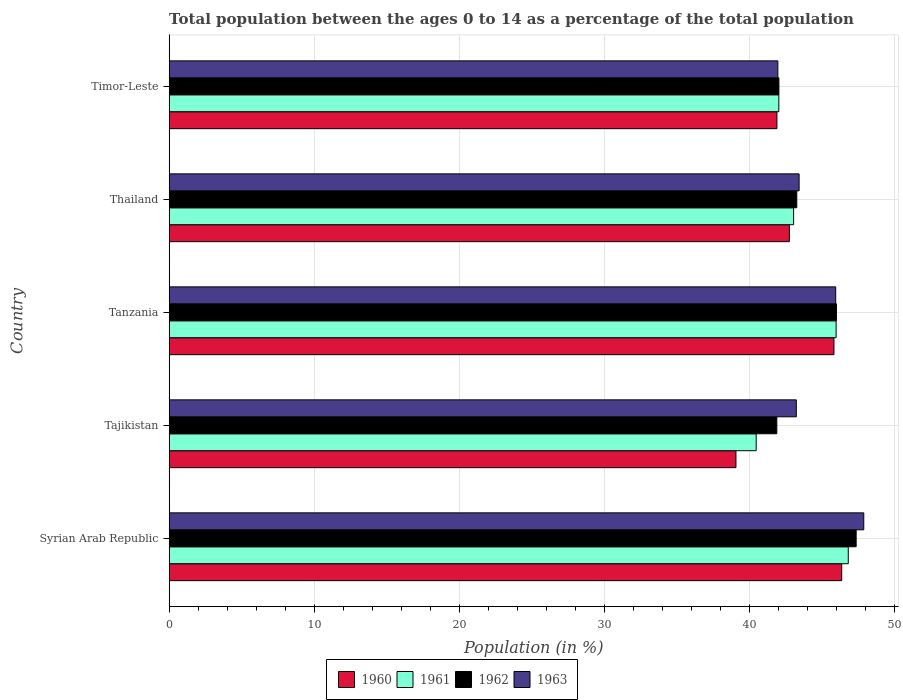How many groups of bars are there?
Offer a terse response. 5. How many bars are there on the 2nd tick from the bottom?
Make the answer very short. 4. What is the label of the 3rd group of bars from the top?
Keep it short and to the point. Tanzania. What is the percentage of the population ages 0 to 14 in 1963 in Tanzania?
Give a very brief answer. 45.93. Across all countries, what is the maximum percentage of the population ages 0 to 14 in 1960?
Offer a terse response. 46.34. Across all countries, what is the minimum percentage of the population ages 0 to 14 in 1962?
Provide a short and direct response. 41.87. In which country was the percentage of the population ages 0 to 14 in 1960 maximum?
Your answer should be very brief. Syrian Arab Republic. In which country was the percentage of the population ages 0 to 14 in 1962 minimum?
Your answer should be compact. Tajikistan. What is the total percentage of the population ages 0 to 14 in 1963 in the graph?
Your answer should be compact. 222.36. What is the difference between the percentage of the population ages 0 to 14 in 1962 in Syrian Arab Republic and that in Timor-Leste?
Offer a very short reply. 5.32. What is the difference between the percentage of the population ages 0 to 14 in 1961 in Timor-Leste and the percentage of the population ages 0 to 14 in 1963 in Thailand?
Provide a succinct answer. -1.4. What is the average percentage of the population ages 0 to 14 in 1960 per country?
Give a very brief answer. 43.16. What is the difference between the percentage of the population ages 0 to 14 in 1962 and percentage of the population ages 0 to 14 in 1960 in Thailand?
Your answer should be compact. 0.51. In how many countries, is the percentage of the population ages 0 to 14 in 1961 greater than 28 ?
Offer a very short reply. 5. What is the ratio of the percentage of the population ages 0 to 14 in 1962 in Tanzania to that in Thailand?
Your answer should be very brief. 1.06. Is the percentage of the population ages 0 to 14 in 1960 in Tanzania less than that in Timor-Leste?
Provide a short and direct response. No. Is the difference between the percentage of the population ages 0 to 14 in 1962 in Tajikistan and Timor-Leste greater than the difference between the percentage of the population ages 0 to 14 in 1960 in Tajikistan and Timor-Leste?
Ensure brevity in your answer.  Yes. What is the difference between the highest and the second highest percentage of the population ages 0 to 14 in 1963?
Provide a short and direct response. 1.93. What is the difference between the highest and the lowest percentage of the population ages 0 to 14 in 1960?
Provide a succinct answer. 7.29. Is the sum of the percentage of the population ages 0 to 14 in 1962 in Syrian Arab Republic and Tanzania greater than the maximum percentage of the population ages 0 to 14 in 1960 across all countries?
Your answer should be compact. Yes. Is it the case that in every country, the sum of the percentage of the population ages 0 to 14 in 1960 and percentage of the population ages 0 to 14 in 1962 is greater than the sum of percentage of the population ages 0 to 14 in 1963 and percentage of the population ages 0 to 14 in 1961?
Make the answer very short. No. What does the 3rd bar from the top in Tanzania represents?
Offer a terse response. 1961. What does the 3rd bar from the bottom in Syrian Arab Republic represents?
Your response must be concise. 1962. Is it the case that in every country, the sum of the percentage of the population ages 0 to 14 in 1961 and percentage of the population ages 0 to 14 in 1962 is greater than the percentage of the population ages 0 to 14 in 1960?
Offer a terse response. Yes. How many bars are there?
Offer a terse response. 20. How many countries are there in the graph?
Make the answer very short. 5. What is the difference between two consecutive major ticks on the X-axis?
Your answer should be compact. 10. Does the graph contain any zero values?
Keep it short and to the point. No. What is the title of the graph?
Provide a short and direct response. Total population between the ages 0 to 14 as a percentage of the total population. Does "1963" appear as one of the legend labels in the graph?
Offer a terse response. Yes. What is the label or title of the X-axis?
Make the answer very short. Population (in %). What is the Population (in %) in 1960 in Syrian Arab Republic?
Make the answer very short. 46.34. What is the Population (in %) of 1961 in Syrian Arab Republic?
Provide a short and direct response. 46.79. What is the Population (in %) in 1962 in Syrian Arab Republic?
Ensure brevity in your answer.  47.34. What is the Population (in %) in 1963 in Syrian Arab Republic?
Your response must be concise. 47.86. What is the Population (in %) in 1960 in Tajikistan?
Provide a short and direct response. 39.06. What is the Population (in %) in 1961 in Tajikistan?
Give a very brief answer. 40.45. What is the Population (in %) in 1962 in Tajikistan?
Your answer should be compact. 41.87. What is the Population (in %) of 1963 in Tajikistan?
Provide a succinct answer. 43.22. What is the Population (in %) in 1960 in Tanzania?
Ensure brevity in your answer.  45.81. What is the Population (in %) of 1961 in Tanzania?
Your answer should be very brief. 45.96. What is the Population (in %) of 1962 in Tanzania?
Give a very brief answer. 45.98. What is the Population (in %) in 1963 in Tanzania?
Your answer should be compact. 45.93. What is the Population (in %) of 1960 in Thailand?
Ensure brevity in your answer.  42.73. What is the Population (in %) of 1961 in Thailand?
Give a very brief answer. 43.03. What is the Population (in %) of 1962 in Thailand?
Make the answer very short. 43.25. What is the Population (in %) of 1963 in Thailand?
Give a very brief answer. 43.41. What is the Population (in %) in 1960 in Timor-Leste?
Make the answer very short. 41.88. What is the Population (in %) of 1961 in Timor-Leste?
Provide a short and direct response. 42.01. What is the Population (in %) of 1962 in Timor-Leste?
Your response must be concise. 42.02. What is the Population (in %) of 1963 in Timor-Leste?
Provide a short and direct response. 41.94. Across all countries, what is the maximum Population (in %) of 1960?
Make the answer very short. 46.34. Across all countries, what is the maximum Population (in %) in 1961?
Your response must be concise. 46.79. Across all countries, what is the maximum Population (in %) of 1962?
Your answer should be compact. 47.34. Across all countries, what is the maximum Population (in %) in 1963?
Your answer should be compact. 47.86. Across all countries, what is the minimum Population (in %) of 1960?
Offer a very short reply. 39.06. Across all countries, what is the minimum Population (in %) of 1961?
Your answer should be very brief. 40.45. Across all countries, what is the minimum Population (in %) of 1962?
Make the answer very short. 41.87. Across all countries, what is the minimum Population (in %) of 1963?
Your answer should be very brief. 41.94. What is the total Population (in %) of 1960 in the graph?
Your answer should be very brief. 215.82. What is the total Population (in %) in 1961 in the graph?
Your answer should be compact. 218.24. What is the total Population (in %) in 1962 in the graph?
Offer a very short reply. 220.45. What is the total Population (in %) of 1963 in the graph?
Your answer should be compact. 222.36. What is the difference between the Population (in %) of 1960 in Syrian Arab Republic and that in Tajikistan?
Offer a very short reply. 7.29. What is the difference between the Population (in %) of 1961 in Syrian Arab Republic and that in Tajikistan?
Your response must be concise. 6.34. What is the difference between the Population (in %) in 1962 in Syrian Arab Republic and that in Tajikistan?
Ensure brevity in your answer.  5.47. What is the difference between the Population (in %) in 1963 in Syrian Arab Republic and that in Tajikistan?
Offer a very short reply. 4.65. What is the difference between the Population (in %) of 1960 in Syrian Arab Republic and that in Tanzania?
Your response must be concise. 0.53. What is the difference between the Population (in %) in 1961 in Syrian Arab Republic and that in Tanzania?
Ensure brevity in your answer.  0.84. What is the difference between the Population (in %) of 1962 in Syrian Arab Republic and that in Tanzania?
Provide a succinct answer. 1.36. What is the difference between the Population (in %) in 1963 in Syrian Arab Republic and that in Tanzania?
Offer a terse response. 1.93. What is the difference between the Population (in %) in 1960 in Syrian Arab Republic and that in Thailand?
Offer a very short reply. 3.61. What is the difference between the Population (in %) of 1961 in Syrian Arab Republic and that in Thailand?
Keep it short and to the point. 3.77. What is the difference between the Population (in %) of 1962 in Syrian Arab Republic and that in Thailand?
Offer a very short reply. 4.09. What is the difference between the Population (in %) in 1963 in Syrian Arab Republic and that in Thailand?
Make the answer very short. 4.46. What is the difference between the Population (in %) in 1960 in Syrian Arab Republic and that in Timor-Leste?
Keep it short and to the point. 4.46. What is the difference between the Population (in %) of 1961 in Syrian Arab Republic and that in Timor-Leste?
Your answer should be very brief. 4.78. What is the difference between the Population (in %) in 1962 in Syrian Arab Republic and that in Timor-Leste?
Make the answer very short. 5.32. What is the difference between the Population (in %) of 1963 in Syrian Arab Republic and that in Timor-Leste?
Give a very brief answer. 5.92. What is the difference between the Population (in %) of 1960 in Tajikistan and that in Tanzania?
Your answer should be compact. -6.75. What is the difference between the Population (in %) of 1961 in Tajikistan and that in Tanzania?
Offer a terse response. -5.51. What is the difference between the Population (in %) of 1962 in Tajikistan and that in Tanzania?
Ensure brevity in your answer.  -4.11. What is the difference between the Population (in %) of 1963 in Tajikistan and that in Tanzania?
Provide a succinct answer. -2.71. What is the difference between the Population (in %) of 1960 in Tajikistan and that in Thailand?
Your answer should be compact. -3.68. What is the difference between the Population (in %) in 1961 in Tajikistan and that in Thailand?
Give a very brief answer. -2.58. What is the difference between the Population (in %) in 1962 in Tajikistan and that in Thailand?
Make the answer very short. -1.38. What is the difference between the Population (in %) of 1963 in Tajikistan and that in Thailand?
Keep it short and to the point. -0.19. What is the difference between the Population (in %) in 1960 in Tajikistan and that in Timor-Leste?
Your response must be concise. -2.82. What is the difference between the Population (in %) in 1961 in Tajikistan and that in Timor-Leste?
Provide a succinct answer. -1.56. What is the difference between the Population (in %) in 1962 in Tajikistan and that in Timor-Leste?
Your response must be concise. -0.14. What is the difference between the Population (in %) in 1963 in Tajikistan and that in Timor-Leste?
Provide a short and direct response. 1.27. What is the difference between the Population (in %) in 1960 in Tanzania and that in Thailand?
Your response must be concise. 3.07. What is the difference between the Population (in %) in 1961 in Tanzania and that in Thailand?
Provide a short and direct response. 2.93. What is the difference between the Population (in %) in 1962 in Tanzania and that in Thailand?
Ensure brevity in your answer.  2.73. What is the difference between the Population (in %) of 1963 in Tanzania and that in Thailand?
Make the answer very short. 2.52. What is the difference between the Population (in %) of 1960 in Tanzania and that in Timor-Leste?
Offer a terse response. 3.93. What is the difference between the Population (in %) of 1961 in Tanzania and that in Timor-Leste?
Your answer should be compact. 3.95. What is the difference between the Population (in %) of 1962 in Tanzania and that in Timor-Leste?
Offer a very short reply. 3.96. What is the difference between the Population (in %) in 1963 in Tanzania and that in Timor-Leste?
Ensure brevity in your answer.  3.99. What is the difference between the Population (in %) of 1960 in Thailand and that in Timor-Leste?
Give a very brief answer. 0.86. What is the difference between the Population (in %) in 1961 in Thailand and that in Timor-Leste?
Make the answer very short. 1.02. What is the difference between the Population (in %) in 1962 in Thailand and that in Timor-Leste?
Your answer should be compact. 1.23. What is the difference between the Population (in %) of 1963 in Thailand and that in Timor-Leste?
Keep it short and to the point. 1.47. What is the difference between the Population (in %) in 1960 in Syrian Arab Republic and the Population (in %) in 1961 in Tajikistan?
Provide a succinct answer. 5.89. What is the difference between the Population (in %) of 1960 in Syrian Arab Republic and the Population (in %) of 1962 in Tajikistan?
Your response must be concise. 4.47. What is the difference between the Population (in %) of 1960 in Syrian Arab Republic and the Population (in %) of 1963 in Tajikistan?
Your answer should be compact. 3.13. What is the difference between the Population (in %) in 1961 in Syrian Arab Republic and the Population (in %) in 1962 in Tajikistan?
Your answer should be compact. 4.92. What is the difference between the Population (in %) in 1961 in Syrian Arab Republic and the Population (in %) in 1963 in Tajikistan?
Make the answer very short. 3.58. What is the difference between the Population (in %) in 1962 in Syrian Arab Republic and the Population (in %) in 1963 in Tajikistan?
Your answer should be very brief. 4.12. What is the difference between the Population (in %) in 1960 in Syrian Arab Republic and the Population (in %) in 1961 in Tanzania?
Make the answer very short. 0.39. What is the difference between the Population (in %) in 1960 in Syrian Arab Republic and the Population (in %) in 1962 in Tanzania?
Offer a terse response. 0.36. What is the difference between the Population (in %) in 1960 in Syrian Arab Republic and the Population (in %) in 1963 in Tanzania?
Offer a terse response. 0.41. What is the difference between the Population (in %) of 1961 in Syrian Arab Republic and the Population (in %) of 1962 in Tanzania?
Keep it short and to the point. 0.81. What is the difference between the Population (in %) of 1961 in Syrian Arab Republic and the Population (in %) of 1963 in Tanzania?
Your response must be concise. 0.87. What is the difference between the Population (in %) of 1962 in Syrian Arab Republic and the Population (in %) of 1963 in Tanzania?
Provide a succinct answer. 1.41. What is the difference between the Population (in %) in 1960 in Syrian Arab Republic and the Population (in %) in 1961 in Thailand?
Provide a short and direct response. 3.31. What is the difference between the Population (in %) in 1960 in Syrian Arab Republic and the Population (in %) in 1962 in Thailand?
Offer a terse response. 3.1. What is the difference between the Population (in %) in 1960 in Syrian Arab Republic and the Population (in %) in 1963 in Thailand?
Give a very brief answer. 2.94. What is the difference between the Population (in %) in 1961 in Syrian Arab Republic and the Population (in %) in 1962 in Thailand?
Your response must be concise. 3.55. What is the difference between the Population (in %) in 1961 in Syrian Arab Republic and the Population (in %) in 1963 in Thailand?
Your response must be concise. 3.39. What is the difference between the Population (in %) in 1962 in Syrian Arab Republic and the Population (in %) in 1963 in Thailand?
Give a very brief answer. 3.93. What is the difference between the Population (in %) of 1960 in Syrian Arab Republic and the Population (in %) of 1961 in Timor-Leste?
Ensure brevity in your answer.  4.33. What is the difference between the Population (in %) in 1960 in Syrian Arab Republic and the Population (in %) in 1962 in Timor-Leste?
Provide a succinct answer. 4.33. What is the difference between the Population (in %) of 1960 in Syrian Arab Republic and the Population (in %) of 1963 in Timor-Leste?
Provide a short and direct response. 4.4. What is the difference between the Population (in %) in 1961 in Syrian Arab Republic and the Population (in %) in 1962 in Timor-Leste?
Give a very brief answer. 4.78. What is the difference between the Population (in %) in 1961 in Syrian Arab Republic and the Population (in %) in 1963 in Timor-Leste?
Make the answer very short. 4.85. What is the difference between the Population (in %) in 1962 in Syrian Arab Republic and the Population (in %) in 1963 in Timor-Leste?
Ensure brevity in your answer.  5.4. What is the difference between the Population (in %) of 1960 in Tajikistan and the Population (in %) of 1961 in Tanzania?
Your answer should be compact. -6.9. What is the difference between the Population (in %) of 1960 in Tajikistan and the Population (in %) of 1962 in Tanzania?
Make the answer very short. -6.92. What is the difference between the Population (in %) in 1960 in Tajikistan and the Population (in %) in 1963 in Tanzania?
Your response must be concise. -6.87. What is the difference between the Population (in %) in 1961 in Tajikistan and the Population (in %) in 1962 in Tanzania?
Keep it short and to the point. -5.53. What is the difference between the Population (in %) of 1961 in Tajikistan and the Population (in %) of 1963 in Tanzania?
Offer a very short reply. -5.48. What is the difference between the Population (in %) in 1962 in Tajikistan and the Population (in %) in 1963 in Tanzania?
Your answer should be very brief. -4.06. What is the difference between the Population (in %) in 1960 in Tajikistan and the Population (in %) in 1961 in Thailand?
Provide a short and direct response. -3.97. What is the difference between the Population (in %) in 1960 in Tajikistan and the Population (in %) in 1962 in Thailand?
Make the answer very short. -4.19. What is the difference between the Population (in %) in 1960 in Tajikistan and the Population (in %) in 1963 in Thailand?
Give a very brief answer. -4.35. What is the difference between the Population (in %) in 1961 in Tajikistan and the Population (in %) in 1962 in Thailand?
Offer a very short reply. -2.8. What is the difference between the Population (in %) in 1961 in Tajikistan and the Population (in %) in 1963 in Thailand?
Offer a terse response. -2.96. What is the difference between the Population (in %) in 1962 in Tajikistan and the Population (in %) in 1963 in Thailand?
Provide a short and direct response. -1.54. What is the difference between the Population (in %) in 1960 in Tajikistan and the Population (in %) in 1961 in Timor-Leste?
Give a very brief answer. -2.95. What is the difference between the Population (in %) of 1960 in Tajikistan and the Population (in %) of 1962 in Timor-Leste?
Offer a very short reply. -2.96. What is the difference between the Population (in %) in 1960 in Tajikistan and the Population (in %) in 1963 in Timor-Leste?
Your answer should be very brief. -2.89. What is the difference between the Population (in %) of 1961 in Tajikistan and the Population (in %) of 1962 in Timor-Leste?
Offer a terse response. -1.57. What is the difference between the Population (in %) in 1961 in Tajikistan and the Population (in %) in 1963 in Timor-Leste?
Offer a terse response. -1.49. What is the difference between the Population (in %) of 1962 in Tajikistan and the Population (in %) of 1963 in Timor-Leste?
Provide a succinct answer. -0.07. What is the difference between the Population (in %) in 1960 in Tanzania and the Population (in %) in 1961 in Thailand?
Your response must be concise. 2.78. What is the difference between the Population (in %) of 1960 in Tanzania and the Population (in %) of 1962 in Thailand?
Give a very brief answer. 2.56. What is the difference between the Population (in %) of 1960 in Tanzania and the Population (in %) of 1963 in Thailand?
Offer a terse response. 2.4. What is the difference between the Population (in %) of 1961 in Tanzania and the Population (in %) of 1962 in Thailand?
Give a very brief answer. 2.71. What is the difference between the Population (in %) of 1961 in Tanzania and the Population (in %) of 1963 in Thailand?
Your answer should be compact. 2.55. What is the difference between the Population (in %) of 1962 in Tanzania and the Population (in %) of 1963 in Thailand?
Keep it short and to the point. 2.57. What is the difference between the Population (in %) of 1960 in Tanzania and the Population (in %) of 1961 in Timor-Leste?
Make the answer very short. 3.8. What is the difference between the Population (in %) in 1960 in Tanzania and the Population (in %) in 1962 in Timor-Leste?
Your response must be concise. 3.79. What is the difference between the Population (in %) of 1960 in Tanzania and the Population (in %) of 1963 in Timor-Leste?
Your answer should be compact. 3.87. What is the difference between the Population (in %) in 1961 in Tanzania and the Population (in %) in 1962 in Timor-Leste?
Ensure brevity in your answer.  3.94. What is the difference between the Population (in %) in 1961 in Tanzania and the Population (in %) in 1963 in Timor-Leste?
Provide a short and direct response. 4.02. What is the difference between the Population (in %) of 1962 in Tanzania and the Population (in %) of 1963 in Timor-Leste?
Keep it short and to the point. 4.04. What is the difference between the Population (in %) in 1960 in Thailand and the Population (in %) in 1961 in Timor-Leste?
Ensure brevity in your answer.  0.72. What is the difference between the Population (in %) in 1960 in Thailand and the Population (in %) in 1962 in Timor-Leste?
Provide a succinct answer. 0.72. What is the difference between the Population (in %) of 1960 in Thailand and the Population (in %) of 1963 in Timor-Leste?
Offer a very short reply. 0.79. What is the difference between the Population (in %) of 1961 in Thailand and the Population (in %) of 1962 in Timor-Leste?
Provide a short and direct response. 1.01. What is the difference between the Population (in %) of 1961 in Thailand and the Population (in %) of 1963 in Timor-Leste?
Your answer should be very brief. 1.09. What is the difference between the Population (in %) in 1962 in Thailand and the Population (in %) in 1963 in Timor-Leste?
Give a very brief answer. 1.3. What is the average Population (in %) in 1960 per country?
Provide a short and direct response. 43.16. What is the average Population (in %) in 1961 per country?
Provide a short and direct response. 43.65. What is the average Population (in %) of 1962 per country?
Ensure brevity in your answer.  44.09. What is the average Population (in %) in 1963 per country?
Provide a short and direct response. 44.47. What is the difference between the Population (in %) in 1960 and Population (in %) in 1961 in Syrian Arab Republic?
Make the answer very short. -0.45. What is the difference between the Population (in %) in 1960 and Population (in %) in 1962 in Syrian Arab Republic?
Keep it short and to the point. -1. What is the difference between the Population (in %) of 1960 and Population (in %) of 1963 in Syrian Arab Republic?
Provide a short and direct response. -1.52. What is the difference between the Population (in %) of 1961 and Population (in %) of 1962 in Syrian Arab Republic?
Ensure brevity in your answer.  -0.54. What is the difference between the Population (in %) in 1961 and Population (in %) in 1963 in Syrian Arab Republic?
Keep it short and to the point. -1.07. What is the difference between the Population (in %) in 1962 and Population (in %) in 1963 in Syrian Arab Republic?
Ensure brevity in your answer.  -0.52. What is the difference between the Population (in %) of 1960 and Population (in %) of 1961 in Tajikistan?
Give a very brief answer. -1.39. What is the difference between the Population (in %) of 1960 and Population (in %) of 1962 in Tajikistan?
Offer a very short reply. -2.81. What is the difference between the Population (in %) in 1960 and Population (in %) in 1963 in Tajikistan?
Your response must be concise. -4.16. What is the difference between the Population (in %) in 1961 and Population (in %) in 1962 in Tajikistan?
Your answer should be compact. -1.42. What is the difference between the Population (in %) of 1961 and Population (in %) of 1963 in Tajikistan?
Ensure brevity in your answer.  -2.77. What is the difference between the Population (in %) of 1962 and Population (in %) of 1963 in Tajikistan?
Ensure brevity in your answer.  -1.34. What is the difference between the Population (in %) in 1960 and Population (in %) in 1961 in Tanzania?
Keep it short and to the point. -0.15. What is the difference between the Population (in %) in 1960 and Population (in %) in 1962 in Tanzania?
Keep it short and to the point. -0.17. What is the difference between the Population (in %) of 1960 and Population (in %) of 1963 in Tanzania?
Your answer should be compact. -0.12. What is the difference between the Population (in %) in 1961 and Population (in %) in 1962 in Tanzania?
Provide a succinct answer. -0.02. What is the difference between the Population (in %) of 1961 and Population (in %) of 1963 in Tanzania?
Your response must be concise. 0.03. What is the difference between the Population (in %) of 1962 and Population (in %) of 1963 in Tanzania?
Make the answer very short. 0.05. What is the difference between the Population (in %) in 1960 and Population (in %) in 1961 in Thailand?
Give a very brief answer. -0.29. What is the difference between the Population (in %) in 1960 and Population (in %) in 1962 in Thailand?
Your response must be concise. -0.51. What is the difference between the Population (in %) in 1960 and Population (in %) in 1963 in Thailand?
Keep it short and to the point. -0.67. What is the difference between the Population (in %) in 1961 and Population (in %) in 1962 in Thailand?
Your answer should be compact. -0.22. What is the difference between the Population (in %) of 1961 and Population (in %) of 1963 in Thailand?
Your answer should be compact. -0.38. What is the difference between the Population (in %) in 1962 and Population (in %) in 1963 in Thailand?
Provide a succinct answer. -0.16. What is the difference between the Population (in %) in 1960 and Population (in %) in 1961 in Timor-Leste?
Offer a very short reply. -0.13. What is the difference between the Population (in %) of 1960 and Population (in %) of 1962 in Timor-Leste?
Your answer should be compact. -0.14. What is the difference between the Population (in %) in 1960 and Population (in %) in 1963 in Timor-Leste?
Provide a succinct answer. -0.06. What is the difference between the Population (in %) of 1961 and Population (in %) of 1962 in Timor-Leste?
Offer a very short reply. -0.01. What is the difference between the Population (in %) in 1961 and Population (in %) in 1963 in Timor-Leste?
Your response must be concise. 0.07. What is the difference between the Population (in %) in 1962 and Population (in %) in 1963 in Timor-Leste?
Offer a very short reply. 0.07. What is the ratio of the Population (in %) of 1960 in Syrian Arab Republic to that in Tajikistan?
Offer a very short reply. 1.19. What is the ratio of the Population (in %) of 1961 in Syrian Arab Republic to that in Tajikistan?
Provide a succinct answer. 1.16. What is the ratio of the Population (in %) in 1962 in Syrian Arab Republic to that in Tajikistan?
Provide a short and direct response. 1.13. What is the ratio of the Population (in %) in 1963 in Syrian Arab Republic to that in Tajikistan?
Offer a very short reply. 1.11. What is the ratio of the Population (in %) of 1960 in Syrian Arab Republic to that in Tanzania?
Your response must be concise. 1.01. What is the ratio of the Population (in %) in 1961 in Syrian Arab Republic to that in Tanzania?
Offer a terse response. 1.02. What is the ratio of the Population (in %) in 1962 in Syrian Arab Republic to that in Tanzania?
Provide a short and direct response. 1.03. What is the ratio of the Population (in %) in 1963 in Syrian Arab Republic to that in Tanzania?
Offer a very short reply. 1.04. What is the ratio of the Population (in %) in 1960 in Syrian Arab Republic to that in Thailand?
Provide a short and direct response. 1.08. What is the ratio of the Population (in %) of 1961 in Syrian Arab Republic to that in Thailand?
Keep it short and to the point. 1.09. What is the ratio of the Population (in %) of 1962 in Syrian Arab Republic to that in Thailand?
Your answer should be compact. 1.09. What is the ratio of the Population (in %) of 1963 in Syrian Arab Republic to that in Thailand?
Offer a very short reply. 1.1. What is the ratio of the Population (in %) in 1960 in Syrian Arab Republic to that in Timor-Leste?
Offer a very short reply. 1.11. What is the ratio of the Population (in %) of 1961 in Syrian Arab Republic to that in Timor-Leste?
Keep it short and to the point. 1.11. What is the ratio of the Population (in %) in 1962 in Syrian Arab Republic to that in Timor-Leste?
Offer a very short reply. 1.13. What is the ratio of the Population (in %) of 1963 in Syrian Arab Republic to that in Timor-Leste?
Your answer should be compact. 1.14. What is the ratio of the Population (in %) of 1960 in Tajikistan to that in Tanzania?
Keep it short and to the point. 0.85. What is the ratio of the Population (in %) of 1961 in Tajikistan to that in Tanzania?
Ensure brevity in your answer.  0.88. What is the ratio of the Population (in %) of 1962 in Tajikistan to that in Tanzania?
Your answer should be compact. 0.91. What is the ratio of the Population (in %) in 1963 in Tajikistan to that in Tanzania?
Offer a terse response. 0.94. What is the ratio of the Population (in %) in 1960 in Tajikistan to that in Thailand?
Your answer should be compact. 0.91. What is the ratio of the Population (in %) of 1961 in Tajikistan to that in Thailand?
Keep it short and to the point. 0.94. What is the ratio of the Population (in %) of 1962 in Tajikistan to that in Thailand?
Ensure brevity in your answer.  0.97. What is the ratio of the Population (in %) of 1963 in Tajikistan to that in Thailand?
Ensure brevity in your answer.  1. What is the ratio of the Population (in %) in 1960 in Tajikistan to that in Timor-Leste?
Provide a succinct answer. 0.93. What is the ratio of the Population (in %) of 1961 in Tajikistan to that in Timor-Leste?
Your response must be concise. 0.96. What is the ratio of the Population (in %) in 1962 in Tajikistan to that in Timor-Leste?
Offer a terse response. 1. What is the ratio of the Population (in %) of 1963 in Tajikistan to that in Timor-Leste?
Your response must be concise. 1.03. What is the ratio of the Population (in %) in 1960 in Tanzania to that in Thailand?
Keep it short and to the point. 1.07. What is the ratio of the Population (in %) of 1961 in Tanzania to that in Thailand?
Offer a terse response. 1.07. What is the ratio of the Population (in %) of 1962 in Tanzania to that in Thailand?
Your response must be concise. 1.06. What is the ratio of the Population (in %) in 1963 in Tanzania to that in Thailand?
Your response must be concise. 1.06. What is the ratio of the Population (in %) of 1960 in Tanzania to that in Timor-Leste?
Provide a short and direct response. 1.09. What is the ratio of the Population (in %) of 1961 in Tanzania to that in Timor-Leste?
Offer a terse response. 1.09. What is the ratio of the Population (in %) of 1962 in Tanzania to that in Timor-Leste?
Provide a succinct answer. 1.09. What is the ratio of the Population (in %) in 1963 in Tanzania to that in Timor-Leste?
Offer a very short reply. 1.1. What is the ratio of the Population (in %) in 1960 in Thailand to that in Timor-Leste?
Make the answer very short. 1.02. What is the ratio of the Population (in %) of 1961 in Thailand to that in Timor-Leste?
Your response must be concise. 1.02. What is the ratio of the Population (in %) in 1962 in Thailand to that in Timor-Leste?
Ensure brevity in your answer.  1.03. What is the ratio of the Population (in %) of 1963 in Thailand to that in Timor-Leste?
Provide a succinct answer. 1.03. What is the difference between the highest and the second highest Population (in %) of 1960?
Offer a very short reply. 0.53. What is the difference between the highest and the second highest Population (in %) of 1961?
Keep it short and to the point. 0.84. What is the difference between the highest and the second highest Population (in %) of 1962?
Offer a terse response. 1.36. What is the difference between the highest and the second highest Population (in %) in 1963?
Your response must be concise. 1.93. What is the difference between the highest and the lowest Population (in %) in 1960?
Offer a terse response. 7.29. What is the difference between the highest and the lowest Population (in %) of 1961?
Give a very brief answer. 6.34. What is the difference between the highest and the lowest Population (in %) in 1962?
Provide a succinct answer. 5.47. What is the difference between the highest and the lowest Population (in %) in 1963?
Provide a short and direct response. 5.92. 